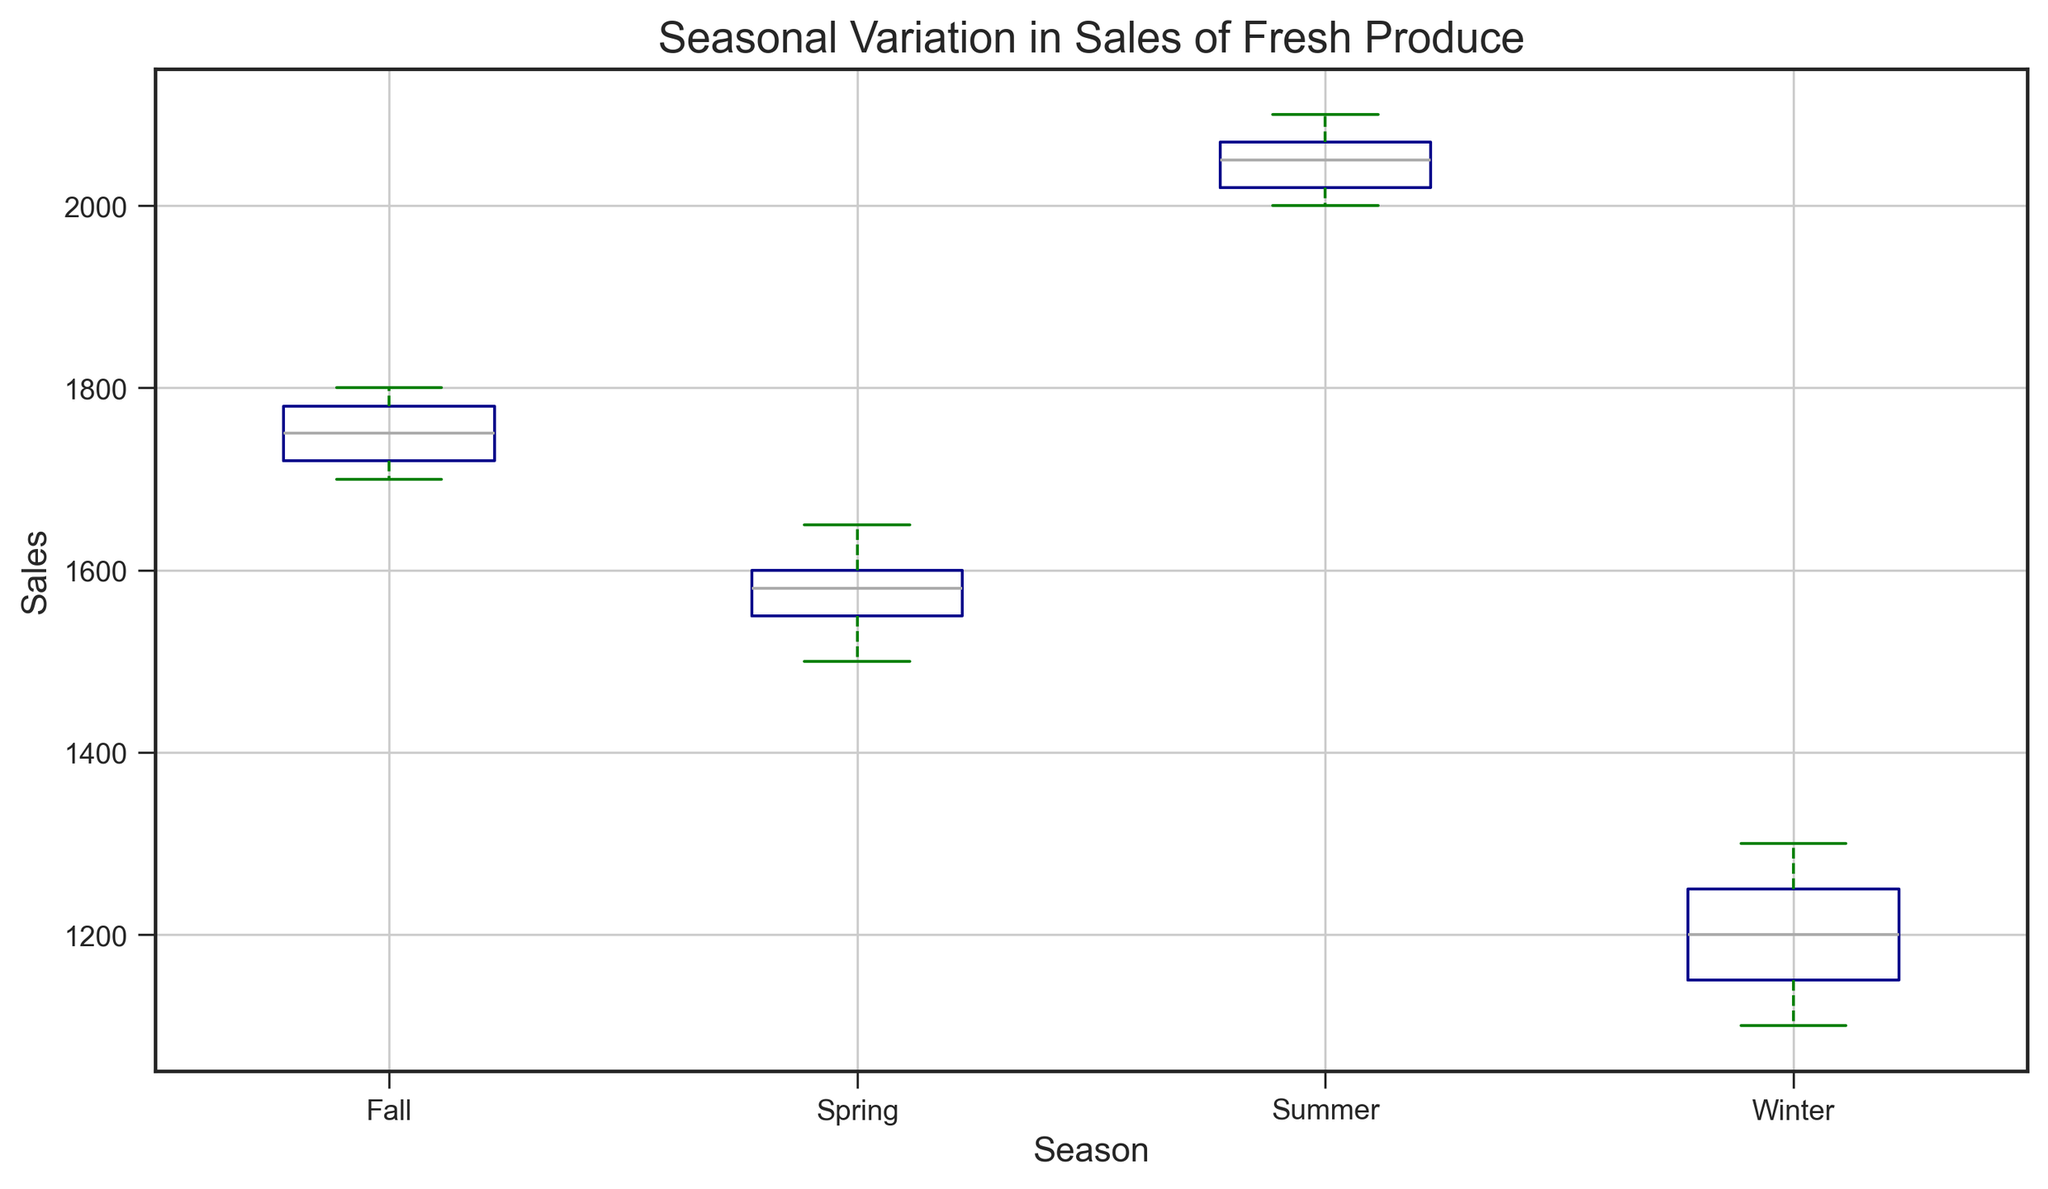Which season has the highest median sales? To find the season with the highest median sales, look at the center line inside each box in the box plot, which represents the median. Observe and compare the median lines for each season.
Answer: Summer What is the interquartile range (IQR) for Winter sales? The IQR is calculated by subtracting the first quartile (Q1) from the third quartile (Q3). Identify the positions of Q1 and Q3 on the box plot for Winter and subtract Q1 from Q3.
Answer: 150 How do the medians of Spring and Fall sales compare? Look at the median lines within the boxes for Spring and Fall. Compare the positions of these lines to see which is higher or if they are equal.
Answer: Spring median is higher Which season has the widest range between the maximum and minimum sales values? To determine the season with the widest range, look at the distance between the top whisker and the bottom whisker (maximum and minimum values) for each season and identify the largest gap.
Answer: Summer Which season shows the most variability in sales data based on the box plot? Variability can be inferred from the length of the box (IQR) and the length of the whiskers. Identify the season with both a large IQR and long whiskers.
Answer: Summer Are there any outliers present in the sales data for Fall? If yes, describe them. Outliers are usually represented by distinct points outside the whiskers of the box plot. Check if there are any points outside the whiskers for Fall.
Answer: No outliers Compare the mean sales values for Winter and Summer based on the box plot. The mean is often marked by a distinct shape (triangle). Locate the mean symbols in the Winter and Summer boxes and compare their positions.
Answer: Summer mean is higher Which season's sales data appears to be the most symmetric? A symmetric distribution will have its median line roughly in the middle of the box and equally spaced whiskers. Identify the season whose box plot attributes match this description.
Answer: Winter If you were to choose a season to predict the least variation in monthly sales, which would it be based on the box plot? Why? The least variation can be inferred from the shortest IQR and shortest whiskers. Identify the season with these attributes.
Answer: Winter, due to the narrowest box and shortest whiskers What is the difference between the median sales for Summer and Winter? First, identify the median lines for Summer and Winter in the box plot. Subtract the Winter median from the Summer median to find the difference.
Answer: 850 